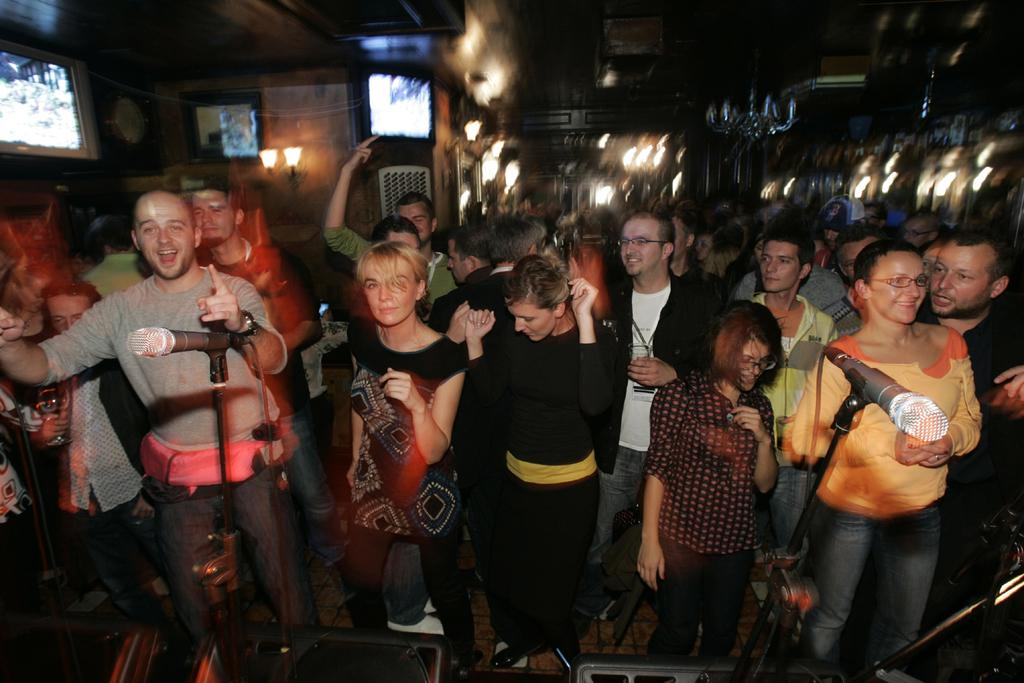What objects are present in the image that are used for amplifying sound? There are two microphones in the image. What can be seen on the floor in the image? There is a group of people standing on the floor. What can be seen in the background of the image? There are lights and screens in the background of the image. How would you describe the background in the image? The background appears blurry. How many channels are available for the group of people to watch on the screens in the image? There is no information about the number of channels available on the screens in the image. Can you tell me if any of the people in the image are slaves? There is no indication of slavery or any related context in the image. 